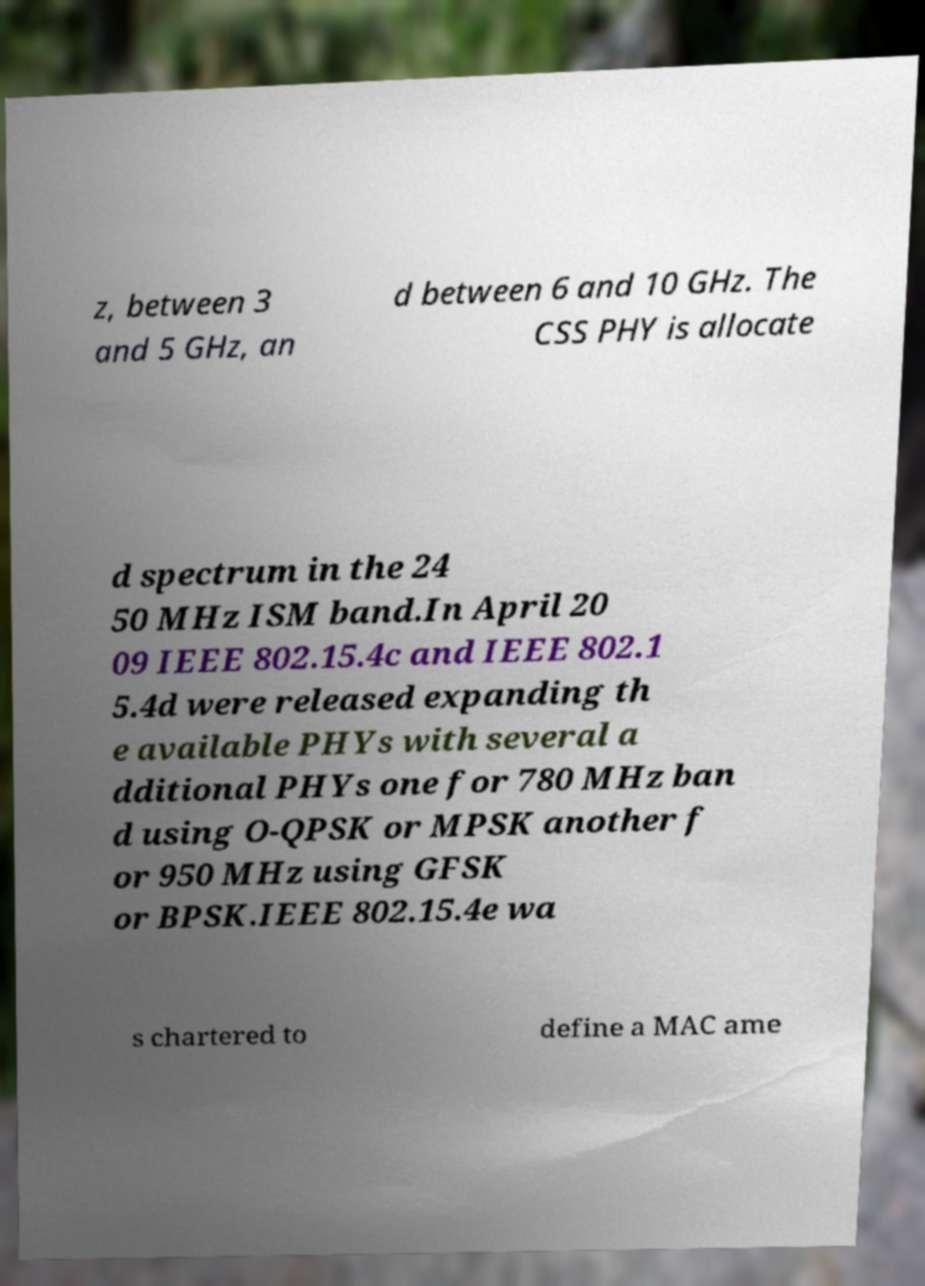What messages or text are displayed in this image? I need them in a readable, typed format. z, between 3 and 5 GHz, an d between 6 and 10 GHz. The CSS PHY is allocate d spectrum in the 24 50 MHz ISM band.In April 20 09 IEEE 802.15.4c and IEEE 802.1 5.4d were released expanding th e available PHYs with several a dditional PHYs one for 780 MHz ban d using O-QPSK or MPSK another f or 950 MHz using GFSK or BPSK.IEEE 802.15.4e wa s chartered to define a MAC ame 